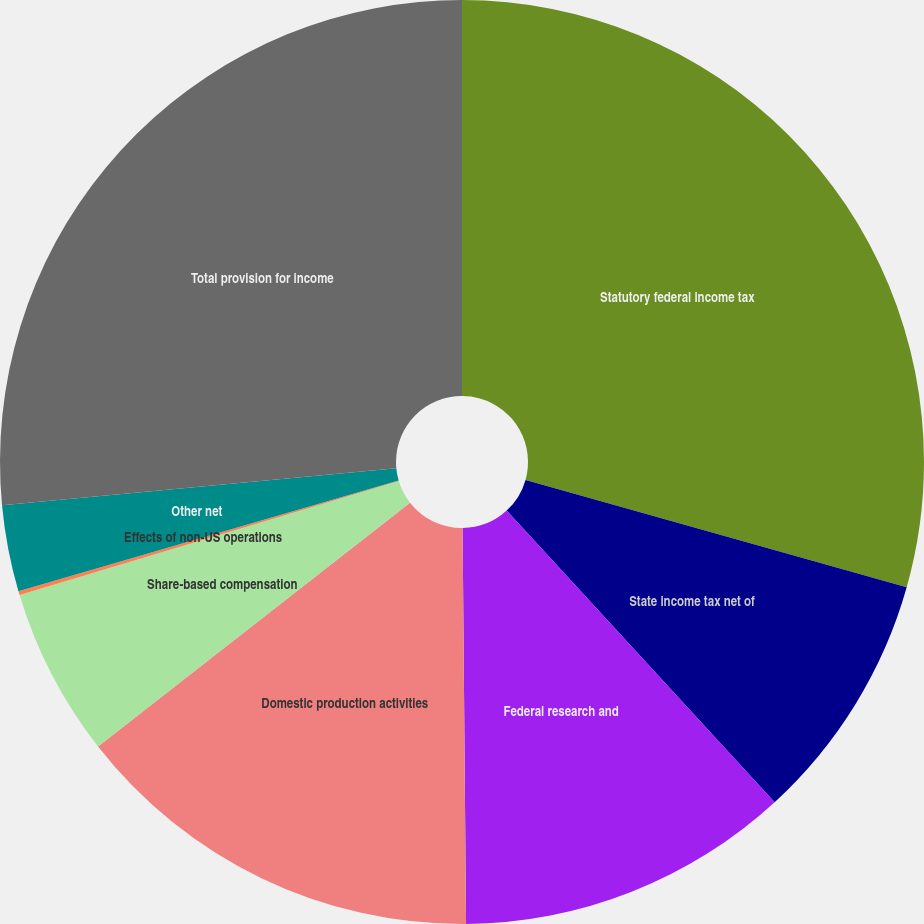Convert chart. <chart><loc_0><loc_0><loc_500><loc_500><pie_chart><fcel>Statutory federal income tax<fcel>State income tax net of<fcel>Federal research and<fcel>Domestic production activities<fcel>Share-based compensation<fcel>Effects of non-US operations<fcel>Other net<fcel>Total provision for income<nl><fcel>29.37%<fcel>8.8%<fcel>11.69%<fcel>14.58%<fcel>5.91%<fcel>0.14%<fcel>3.02%<fcel>26.49%<nl></chart> 